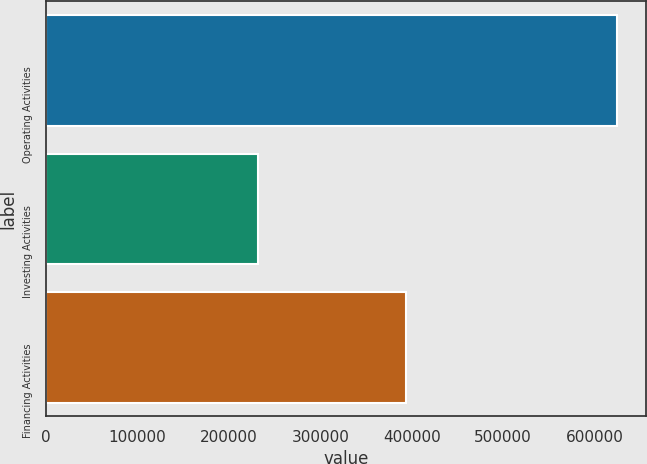Convert chart. <chart><loc_0><loc_0><loc_500><loc_500><bar_chart><fcel>Operating Activities<fcel>Investing Activities<fcel>Financing Activities<nl><fcel>624927<fcel>231497<fcel>394140<nl></chart> 